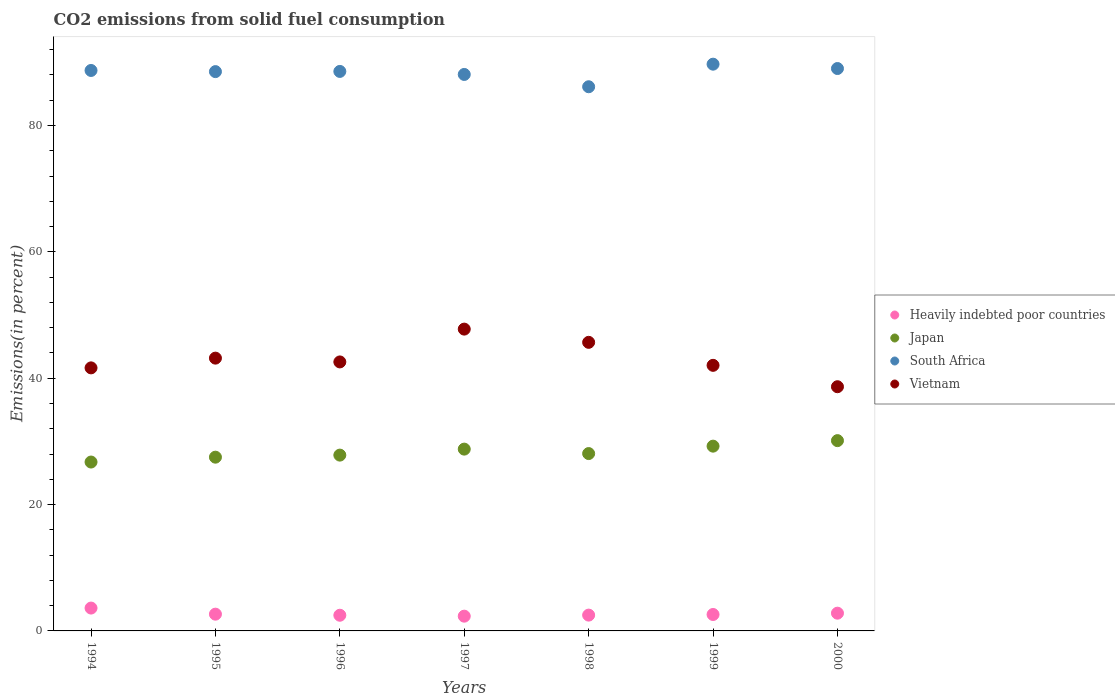Is the number of dotlines equal to the number of legend labels?
Ensure brevity in your answer.  Yes. What is the total CO2 emitted in Heavily indebted poor countries in 1994?
Provide a succinct answer. 3.62. Across all years, what is the maximum total CO2 emitted in Heavily indebted poor countries?
Make the answer very short. 3.62. Across all years, what is the minimum total CO2 emitted in South Africa?
Your response must be concise. 86.13. What is the total total CO2 emitted in Heavily indebted poor countries in the graph?
Your response must be concise. 19. What is the difference between the total CO2 emitted in Heavily indebted poor countries in 1995 and that in 1997?
Provide a succinct answer. 0.32. What is the difference between the total CO2 emitted in Japan in 1994 and the total CO2 emitted in Vietnam in 2000?
Offer a terse response. -11.92. What is the average total CO2 emitted in Heavily indebted poor countries per year?
Provide a succinct answer. 2.71. In the year 1994, what is the difference between the total CO2 emitted in Vietnam and total CO2 emitted in South Africa?
Make the answer very short. -47.07. In how many years, is the total CO2 emitted in Heavily indebted poor countries greater than 56 %?
Your response must be concise. 0. What is the ratio of the total CO2 emitted in Japan in 1994 to that in 2000?
Your answer should be compact. 0.89. What is the difference between the highest and the second highest total CO2 emitted in Heavily indebted poor countries?
Your response must be concise. 0.81. What is the difference between the highest and the lowest total CO2 emitted in South Africa?
Offer a terse response. 3.57. Is the sum of the total CO2 emitted in Vietnam in 1996 and 1998 greater than the maximum total CO2 emitted in South Africa across all years?
Provide a short and direct response. No. Does the total CO2 emitted in Heavily indebted poor countries monotonically increase over the years?
Give a very brief answer. No. Is the total CO2 emitted in Heavily indebted poor countries strictly greater than the total CO2 emitted in South Africa over the years?
Keep it short and to the point. No. Is the total CO2 emitted in Japan strictly less than the total CO2 emitted in South Africa over the years?
Offer a very short reply. Yes. How many dotlines are there?
Your response must be concise. 4. Does the graph contain any zero values?
Offer a terse response. No. Does the graph contain grids?
Provide a short and direct response. No. How many legend labels are there?
Provide a short and direct response. 4. What is the title of the graph?
Give a very brief answer. CO2 emissions from solid fuel consumption. Does "Virgin Islands" appear as one of the legend labels in the graph?
Provide a succinct answer. No. What is the label or title of the Y-axis?
Ensure brevity in your answer.  Emissions(in percent). What is the Emissions(in percent) in Heavily indebted poor countries in 1994?
Offer a very short reply. 3.62. What is the Emissions(in percent) in Japan in 1994?
Your answer should be compact. 26.73. What is the Emissions(in percent) in South Africa in 1994?
Ensure brevity in your answer.  88.7. What is the Emissions(in percent) of Vietnam in 1994?
Offer a terse response. 41.63. What is the Emissions(in percent) of Heavily indebted poor countries in 1995?
Your answer should be compact. 2.65. What is the Emissions(in percent) in Japan in 1995?
Your response must be concise. 27.5. What is the Emissions(in percent) of South Africa in 1995?
Your response must be concise. 88.52. What is the Emissions(in percent) in Vietnam in 1995?
Make the answer very short. 43.17. What is the Emissions(in percent) of Heavily indebted poor countries in 1996?
Your answer should be compact. 2.48. What is the Emissions(in percent) of Japan in 1996?
Your answer should be very brief. 27.83. What is the Emissions(in percent) of South Africa in 1996?
Your answer should be very brief. 88.55. What is the Emissions(in percent) in Vietnam in 1996?
Your answer should be very brief. 42.57. What is the Emissions(in percent) of Heavily indebted poor countries in 1997?
Make the answer very short. 2.34. What is the Emissions(in percent) in Japan in 1997?
Offer a terse response. 28.77. What is the Emissions(in percent) in South Africa in 1997?
Offer a very short reply. 88.07. What is the Emissions(in percent) in Vietnam in 1997?
Offer a very short reply. 47.77. What is the Emissions(in percent) in Heavily indebted poor countries in 1998?
Keep it short and to the point. 2.5. What is the Emissions(in percent) of Japan in 1998?
Your answer should be compact. 28.07. What is the Emissions(in percent) in South Africa in 1998?
Your response must be concise. 86.13. What is the Emissions(in percent) in Vietnam in 1998?
Provide a succinct answer. 45.67. What is the Emissions(in percent) in Heavily indebted poor countries in 1999?
Provide a succinct answer. 2.6. What is the Emissions(in percent) in Japan in 1999?
Keep it short and to the point. 29.24. What is the Emissions(in percent) in South Africa in 1999?
Keep it short and to the point. 89.7. What is the Emissions(in percent) in Vietnam in 1999?
Make the answer very short. 42.03. What is the Emissions(in percent) of Heavily indebted poor countries in 2000?
Provide a short and direct response. 2.81. What is the Emissions(in percent) in Japan in 2000?
Give a very brief answer. 30.12. What is the Emissions(in percent) in South Africa in 2000?
Give a very brief answer. 89.01. What is the Emissions(in percent) in Vietnam in 2000?
Your answer should be very brief. 38.65. Across all years, what is the maximum Emissions(in percent) of Heavily indebted poor countries?
Provide a succinct answer. 3.62. Across all years, what is the maximum Emissions(in percent) of Japan?
Offer a very short reply. 30.12. Across all years, what is the maximum Emissions(in percent) of South Africa?
Provide a succinct answer. 89.7. Across all years, what is the maximum Emissions(in percent) of Vietnam?
Your answer should be very brief. 47.77. Across all years, what is the minimum Emissions(in percent) in Heavily indebted poor countries?
Provide a short and direct response. 2.34. Across all years, what is the minimum Emissions(in percent) of Japan?
Offer a very short reply. 26.73. Across all years, what is the minimum Emissions(in percent) of South Africa?
Provide a succinct answer. 86.13. Across all years, what is the minimum Emissions(in percent) of Vietnam?
Offer a terse response. 38.65. What is the total Emissions(in percent) in Heavily indebted poor countries in the graph?
Offer a very short reply. 19. What is the total Emissions(in percent) of Japan in the graph?
Give a very brief answer. 198.26. What is the total Emissions(in percent) in South Africa in the graph?
Your answer should be very brief. 618.69. What is the total Emissions(in percent) of Vietnam in the graph?
Your answer should be very brief. 301.51. What is the difference between the Emissions(in percent) of Heavily indebted poor countries in 1994 and that in 1995?
Offer a terse response. 0.97. What is the difference between the Emissions(in percent) of Japan in 1994 and that in 1995?
Ensure brevity in your answer.  -0.77. What is the difference between the Emissions(in percent) of South Africa in 1994 and that in 1995?
Give a very brief answer. 0.18. What is the difference between the Emissions(in percent) in Vietnam in 1994 and that in 1995?
Your answer should be compact. -1.54. What is the difference between the Emissions(in percent) in Heavily indebted poor countries in 1994 and that in 1996?
Make the answer very short. 1.14. What is the difference between the Emissions(in percent) in Japan in 1994 and that in 1996?
Ensure brevity in your answer.  -1.1. What is the difference between the Emissions(in percent) in South Africa in 1994 and that in 1996?
Ensure brevity in your answer.  0.15. What is the difference between the Emissions(in percent) in Vietnam in 1994 and that in 1996?
Keep it short and to the point. -0.94. What is the difference between the Emissions(in percent) of Heavily indebted poor countries in 1994 and that in 1997?
Give a very brief answer. 1.28. What is the difference between the Emissions(in percent) of Japan in 1994 and that in 1997?
Ensure brevity in your answer.  -2.04. What is the difference between the Emissions(in percent) of South Africa in 1994 and that in 1997?
Provide a short and direct response. 0.63. What is the difference between the Emissions(in percent) of Vietnam in 1994 and that in 1997?
Your answer should be compact. -6.14. What is the difference between the Emissions(in percent) in Heavily indebted poor countries in 1994 and that in 1998?
Your answer should be compact. 1.11. What is the difference between the Emissions(in percent) in Japan in 1994 and that in 1998?
Your response must be concise. -1.34. What is the difference between the Emissions(in percent) of South Africa in 1994 and that in 1998?
Offer a very short reply. 2.58. What is the difference between the Emissions(in percent) of Vietnam in 1994 and that in 1998?
Your response must be concise. -4.04. What is the difference between the Emissions(in percent) of Heavily indebted poor countries in 1994 and that in 1999?
Provide a succinct answer. 1.02. What is the difference between the Emissions(in percent) of Japan in 1994 and that in 1999?
Offer a terse response. -2.51. What is the difference between the Emissions(in percent) of South Africa in 1994 and that in 1999?
Your answer should be compact. -1. What is the difference between the Emissions(in percent) of Vietnam in 1994 and that in 1999?
Make the answer very short. -0.4. What is the difference between the Emissions(in percent) in Heavily indebted poor countries in 1994 and that in 2000?
Your answer should be compact. 0.81. What is the difference between the Emissions(in percent) in Japan in 1994 and that in 2000?
Your answer should be compact. -3.39. What is the difference between the Emissions(in percent) of South Africa in 1994 and that in 2000?
Offer a terse response. -0.31. What is the difference between the Emissions(in percent) in Vietnam in 1994 and that in 2000?
Provide a succinct answer. 2.98. What is the difference between the Emissions(in percent) of Heavily indebted poor countries in 1995 and that in 1996?
Keep it short and to the point. 0.17. What is the difference between the Emissions(in percent) of Japan in 1995 and that in 1996?
Offer a very short reply. -0.33. What is the difference between the Emissions(in percent) of South Africa in 1995 and that in 1996?
Offer a terse response. -0.03. What is the difference between the Emissions(in percent) in Vietnam in 1995 and that in 1996?
Give a very brief answer. 0.6. What is the difference between the Emissions(in percent) in Heavily indebted poor countries in 1995 and that in 1997?
Offer a very short reply. 0.32. What is the difference between the Emissions(in percent) of Japan in 1995 and that in 1997?
Offer a very short reply. -1.27. What is the difference between the Emissions(in percent) in South Africa in 1995 and that in 1997?
Keep it short and to the point. 0.45. What is the difference between the Emissions(in percent) in Vietnam in 1995 and that in 1997?
Offer a very short reply. -4.59. What is the difference between the Emissions(in percent) of Heavily indebted poor countries in 1995 and that in 1998?
Make the answer very short. 0.15. What is the difference between the Emissions(in percent) in Japan in 1995 and that in 1998?
Offer a very short reply. -0.57. What is the difference between the Emissions(in percent) in South Africa in 1995 and that in 1998?
Provide a short and direct response. 2.39. What is the difference between the Emissions(in percent) of Vietnam in 1995 and that in 1998?
Provide a short and direct response. -2.5. What is the difference between the Emissions(in percent) in Heavily indebted poor countries in 1995 and that in 1999?
Your answer should be very brief. 0.05. What is the difference between the Emissions(in percent) of Japan in 1995 and that in 1999?
Offer a very short reply. -1.74. What is the difference between the Emissions(in percent) of South Africa in 1995 and that in 1999?
Provide a short and direct response. -1.18. What is the difference between the Emissions(in percent) of Vietnam in 1995 and that in 1999?
Give a very brief answer. 1.14. What is the difference between the Emissions(in percent) in Heavily indebted poor countries in 1995 and that in 2000?
Make the answer very short. -0.16. What is the difference between the Emissions(in percent) of Japan in 1995 and that in 2000?
Give a very brief answer. -2.62. What is the difference between the Emissions(in percent) in South Africa in 1995 and that in 2000?
Provide a short and direct response. -0.49. What is the difference between the Emissions(in percent) of Vietnam in 1995 and that in 2000?
Provide a succinct answer. 4.52. What is the difference between the Emissions(in percent) of Heavily indebted poor countries in 1996 and that in 1997?
Give a very brief answer. 0.15. What is the difference between the Emissions(in percent) in Japan in 1996 and that in 1997?
Your answer should be very brief. -0.95. What is the difference between the Emissions(in percent) of South Africa in 1996 and that in 1997?
Offer a very short reply. 0.48. What is the difference between the Emissions(in percent) in Vietnam in 1996 and that in 1997?
Your response must be concise. -5.19. What is the difference between the Emissions(in percent) of Heavily indebted poor countries in 1996 and that in 1998?
Offer a terse response. -0.02. What is the difference between the Emissions(in percent) in Japan in 1996 and that in 1998?
Offer a very short reply. -0.25. What is the difference between the Emissions(in percent) in South Africa in 1996 and that in 1998?
Offer a terse response. 2.43. What is the difference between the Emissions(in percent) of Vietnam in 1996 and that in 1998?
Your answer should be very brief. -3.1. What is the difference between the Emissions(in percent) in Heavily indebted poor countries in 1996 and that in 1999?
Give a very brief answer. -0.12. What is the difference between the Emissions(in percent) in Japan in 1996 and that in 1999?
Give a very brief answer. -1.42. What is the difference between the Emissions(in percent) of South Africa in 1996 and that in 1999?
Offer a very short reply. -1.15. What is the difference between the Emissions(in percent) in Vietnam in 1996 and that in 1999?
Your answer should be compact. 0.54. What is the difference between the Emissions(in percent) in Heavily indebted poor countries in 1996 and that in 2000?
Provide a short and direct response. -0.33. What is the difference between the Emissions(in percent) of Japan in 1996 and that in 2000?
Your answer should be compact. -2.29. What is the difference between the Emissions(in percent) in South Africa in 1996 and that in 2000?
Make the answer very short. -0.46. What is the difference between the Emissions(in percent) in Vietnam in 1996 and that in 2000?
Your response must be concise. 3.93. What is the difference between the Emissions(in percent) in Heavily indebted poor countries in 1997 and that in 1998?
Make the answer very short. -0.17. What is the difference between the Emissions(in percent) in Japan in 1997 and that in 1998?
Offer a very short reply. 0.7. What is the difference between the Emissions(in percent) of South Africa in 1997 and that in 1998?
Make the answer very short. 1.95. What is the difference between the Emissions(in percent) in Vietnam in 1997 and that in 1998?
Offer a terse response. 2.09. What is the difference between the Emissions(in percent) of Heavily indebted poor countries in 1997 and that in 1999?
Provide a short and direct response. -0.26. What is the difference between the Emissions(in percent) of Japan in 1997 and that in 1999?
Keep it short and to the point. -0.47. What is the difference between the Emissions(in percent) in South Africa in 1997 and that in 1999?
Your response must be concise. -1.63. What is the difference between the Emissions(in percent) in Vietnam in 1997 and that in 1999?
Offer a very short reply. 5.73. What is the difference between the Emissions(in percent) in Heavily indebted poor countries in 1997 and that in 2000?
Ensure brevity in your answer.  -0.47. What is the difference between the Emissions(in percent) of Japan in 1997 and that in 2000?
Provide a short and direct response. -1.34. What is the difference between the Emissions(in percent) in South Africa in 1997 and that in 2000?
Your answer should be compact. -0.94. What is the difference between the Emissions(in percent) of Vietnam in 1997 and that in 2000?
Offer a terse response. 9.12. What is the difference between the Emissions(in percent) of Heavily indebted poor countries in 1998 and that in 1999?
Your answer should be very brief. -0.1. What is the difference between the Emissions(in percent) of Japan in 1998 and that in 1999?
Ensure brevity in your answer.  -1.17. What is the difference between the Emissions(in percent) of South Africa in 1998 and that in 1999?
Your response must be concise. -3.57. What is the difference between the Emissions(in percent) in Vietnam in 1998 and that in 1999?
Your answer should be compact. 3.64. What is the difference between the Emissions(in percent) in Heavily indebted poor countries in 1998 and that in 2000?
Your answer should be very brief. -0.3. What is the difference between the Emissions(in percent) of Japan in 1998 and that in 2000?
Your response must be concise. -2.05. What is the difference between the Emissions(in percent) of South Africa in 1998 and that in 2000?
Provide a short and direct response. -2.88. What is the difference between the Emissions(in percent) in Vietnam in 1998 and that in 2000?
Provide a short and direct response. 7.02. What is the difference between the Emissions(in percent) of Heavily indebted poor countries in 1999 and that in 2000?
Your answer should be very brief. -0.21. What is the difference between the Emissions(in percent) of Japan in 1999 and that in 2000?
Keep it short and to the point. -0.87. What is the difference between the Emissions(in percent) in South Africa in 1999 and that in 2000?
Your answer should be compact. 0.69. What is the difference between the Emissions(in percent) of Vietnam in 1999 and that in 2000?
Ensure brevity in your answer.  3.39. What is the difference between the Emissions(in percent) in Heavily indebted poor countries in 1994 and the Emissions(in percent) in Japan in 1995?
Give a very brief answer. -23.88. What is the difference between the Emissions(in percent) of Heavily indebted poor countries in 1994 and the Emissions(in percent) of South Africa in 1995?
Provide a short and direct response. -84.9. What is the difference between the Emissions(in percent) in Heavily indebted poor countries in 1994 and the Emissions(in percent) in Vietnam in 1995?
Your answer should be very brief. -39.56. What is the difference between the Emissions(in percent) of Japan in 1994 and the Emissions(in percent) of South Africa in 1995?
Give a very brief answer. -61.79. What is the difference between the Emissions(in percent) of Japan in 1994 and the Emissions(in percent) of Vietnam in 1995?
Provide a short and direct response. -16.44. What is the difference between the Emissions(in percent) in South Africa in 1994 and the Emissions(in percent) in Vietnam in 1995?
Offer a terse response. 45.53. What is the difference between the Emissions(in percent) in Heavily indebted poor countries in 1994 and the Emissions(in percent) in Japan in 1996?
Ensure brevity in your answer.  -24.21. What is the difference between the Emissions(in percent) in Heavily indebted poor countries in 1994 and the Emissions(in percent) in South Africa in 1996?
Your response must be concise. -84.93. What is the difference between the Emissions(in percent) of Heavily indebted poor countries in 1994 and the Emissions(in percent) of Vietnam in 1996?
Make the answer very short. -38.96. What is the difference between the Emissions(in percent) of Japan in 1994 and the Emissions(in percent) of South Africa in 1996?
Your response must be concise. -61.82. What is the difference between the Emissions(in percent) in Japan in 1994 and the Emissions(in percent) in Vietnam in 1996?
Make the answer very short. -15.85. What is the difference between the Emissions(in percent) of South Africa in 1994 and the Emissions(in percent) of Vietnam in 1996?
Keep it short and to the point. 46.13. What is the difference between the Emissions(in percent) of Heavily indebted poor countries in 1994 and the Emissions(in percent) of Japan in 1997?
Ensure brevity in your answer.  -25.16. What is the difference between the Emissions(in percent) in Heavily indebted poor countries in 1994 and the Emissions(in percent) in South Africa in 1997?
Provide a succinct answer. -84.46. What is the difference between the Emissions(in percent) in Heavily indebted poor countries in 1994 and the Emissions(in percent) in Vietnam in 1997?
Your answer should be compact. -44.15. What is the difference between the Emissions(in percent) of Japan in 1994 and the Emissions(in percent) of South Africa in 1997?
Provide a short and direct response. -61.34. What is the difference between the Emissions(in percent) of Japan in 1994 and the Emissions(in percent) of Vietnam in 1997?
Your answer should be compact. -21.04. What is the difference between the Emissions(in percent) of South Africa in 1994 and the Emissions(in percent) of Vietnam in 1997?
Your answer should be very brief. 40.94. What is the difference between the Emissions(in percent) in Heavily indebted poor countries in 1994 and the Emissions(in percent) in Japan in 1998?
Your answer should be very brief. -24.45. What is the difference between the Emissions(in percent) of Heavily indebted poor countries in 1994 and the Emissions(in percent) of South Africa in 1998?
Offer a terse response. -82.51. What is the difference between the Emissions(in percent) in Heavily indebted poor countries in 1994 and the Emissions(in percent) in Vietnam in 1998?
Make the answer very short. -42.06. What is the difference between the Emissions(in percent) in Japan in 1994 and the Emissions(in percent) in South Africa in 1998?
Offer a terse response. -59.4. What is the difference between the Emissions(in percent) of Japan in 1994 and the Emissions(in percent) of Vietnam in 1998?
Provide a short and direct response. -18.94. What is the difference between the Emissions(in percent) in South Africa in 1994 and the Emissions(in percent) in Vietnam in 1998?
Give a very brief answer. 43.03. What is the difference between the Emissions(in percent) of Heavily indebted poor countries in 1994 and the Emissions(in percent) of Japan in 1999?
Give a very brief answer. -25.63. What is the difference between the Emissions(in percent) of Heavily indebted poor countries in 1994 and the Emissions(in percent) of South Africa in 1999?
Ensure brevity in your answer.  -86.08. What is the difference between the Emissions(in percent) in Heavily indebted poor countries in 1994 and the Emissions(in percent) in Vietnam in 1999?
Provide a short and direct response. -38.42. What is the difference between the Emissions(in percent) in Japan in 1994 and the Emissions(in percent) in South Africa in 1999?
Offer a very short reply. -62.97. What is the difference between the Emissions(in percent) in Japan in 1994 and the Emissions(in percent) in Vietnam in 1999?
Offer a very short reply. -15.3. What is the difference between the Emissions(in percent) of South Africa in 1994 and the Emissions(in percent) of Vietnam in 1999?
Your answer should be very brief. 46.67. What is the difference between the Emissions(in percent) of Heavily indebted poor countries in 1994 and the Emissions(in percent) of Japan in 2000?
Offer a very short reply. -26.5. What is the difference between the Emissions(in percent) of Heavily indebted poor countries in 1994 and the Emissions(in percent) of South Africa in 2000?
Offer a terse response. -85.39. What is the difference between the Emissions(in percent) of Heavily indebted poor countries in 1994 and the Emissions(in percent) of Vietnam in 2000?
Your response must be concise. -35.03. What is the difference between the Emissions(in percent) of Japan in 1994 and the Emissions(in percent) of South Africa in 2000?
Offer a terse response. -62.28. What is the difference between the Emissions(in percent) in Japan in 1994 and the Emissions(in percent) in Vietnam in 2000?
Offer a very short reply. -11.92. What is the difference between the Emissions(in percent) in South Africa in 1994 and the Emissions(in percent) in Vietnam in 2000?
Make the answer very short. 50.05. What is the difference between the Emissions(in percent) in Heavily indebted poor countries in 1995 and the Emissions(in percent) in Japan in 1996?
Your response must be concise. -25.17. What is the difference between the Emissions(in percent) in Heavily indebted poor countries in 1995 and the Emissions(in percent) in South Africa in 1996?
Provide a succinct answer. -85.9. What is the difference between the Emissions(in percent) in Heavily indebted poor countries in 1995 and the Emissions(in percent) in Vietnam in 1996?
Your response must be concise. -39.92. What is the difference between the Emissions(in percent) in Japan in 1995 and the Emissions(in percent) in South Africa in 1996?
Keep it short and to the point. -61.05. What is the difference between the Emissions(in percent) of Japan in 1995 and the Emissions(in percent) of Vietnam in 1996?
Your answer should be very brief. -15.08. What is the difference between the Emissions(in percent) in South Africa in 1995 and the Emissions(in percent) in Vietnam in 1996?
Ensure brevity in your answer.  45.95. What is the difference between the Emissions(in percent) of Heavily indebted poor countries in 1995 and the Emissions(in percent) of Japan in 1997?
Make the answer very short. -26.12. What is the difference between the Emissions(in percent) of Heavily indebted poor countries in 1995 and the Emissions(in percent) of South Africa in 1997?
Make the answer very short. -85.42. What is the difference between the Emissions(in percent) in Heavily indebted poor countries in 1995 and the Emissions(in percent) in Vietnam in 1997?
Keep it short and to the point. -45.12. What is the difference between the Emissions(in percent) of Japan in 1995 and the Emissions(in percent) of South Africa in 1997?
Your response must be concise. -60.58. What is the difference between the Emissions(in percent) in Japan in 1995 and the Emissions(in percent) in Vietnam in 1997?
Offer a terse response. -20.27. What is the difference between the Emissions(in percent) in South Africa in 1995 and the Emissions(in percent) in Vietnam in 1997?
Make the answer very short. 40.75. What is the difference between the Emissions(in percent) in Heavily indebted poor countries in 1995 and the Emissions(in percent) in Japan in 1998?
Your answer should be very brief. -25.42. What is the difference between the Emissions(in percent) of Heavily indebted poor countries in 1995 and the Emissions(in percent) of South Africa in 1998?
Keep it short and to the point. -83.47. What is the difference between the Emissions(in percent) of Heavily indebted poor countries in 1995 and the Emissions(in percent) of Vietnam in 1998?
Ensure brevity in your answer.  -43.02. What is the difference between the Emissions(in percent) in Japan in 1995 and the Emissions(in percent) in South Africa in 1998?
Provide a succinct answer. -58.63. What is the difference between the Emissions(in percent) of Japan in 1995 and the Emissions(in percent) of Vietnam in 1998?
Your answer should be very brief. -18.17. What is the difference between the Emissions(in percent) in South Africa in 1995 and the Emissions(in percent) in Vietnam in 1998?
Provide a succinct answer. 42.85. What is the difference between the Emissions(in percent) in Heavily indebted poor countries in 1995 and the Emissions(in percent) in Japan in 1999?
Your answer should be compact. -26.59. What is the difference between the Emissions(in percent) in Heavily indebted poor countries in 1995 and the Emissions(in percent) in South Africa in 1999?
Provide a short and direct response. -87.05. What is the difference between the Emissions(in percent) in Heavily indebted poor countries in 1995 and the Emissions(in percent) in Vietnam in 1999?
Provide a short and direct response. -39.38. What is the difference between the Emissions(in percent) of Japan in 1995 and the Emissions(in percent) of South Africa in 1999?
Keep it short and to the point. -62.2. What is the difference between the Emissions(in percent) in Japan in 1995 and the Emissions(in percent) in Vietnam in 1999?
Offer a very short reply. -14.53. What is the difference between the Emissions(in percent) of South Africa in 1995 and the Emissions(in percent) of Vietnam in 1999?
Keep it short and to the point. 46.49. What is the difference between the Emissions(in percent) in Heavily indebted poor countries in 1995 and the Emissions(in percent) in Japan in 2000?
Offer a terse response. -27.47. What is the difference between the Emissions(in percent) of Heavily indebted poor countries in 1995 and the Emissions(in percent) of South Africa in 2000?
Your response must be concise. -86.36. What is the difference between the Emissions(in percent) in Heavily indebted poor countries in 1995 and the Emissions(in percent) in Vietnam in 2000?
Your answer should be very brief. -36. What is the difference between the Emissions(in percent) of Japan in 1995 and the Emissions(in percent) of South Africa in 2000?
Offer a terse response. -61.51. What is the difference between the Emissions(in percent) of Japan in 1995 and the Emissions(in percent) of Vietnam in 2000?
Provide a short and direct response. -11.15. What is the difference between the Emissions(in percent) of South Africa in 1995 and the Emissions(in percent) of Vietnam in 2000?
Offer a very short reply. 49.87. What is the difference between the Emissions(in percent) of Heavily indebted poor countries in 1996 and the Emissions(in percent) of Japan in 1997?
Your answer should be compact. -26.29. What is the difference between the Emissions(in percent) of Heavily indebted poor countries in 1996 and the Emissions(in percent) of South Africa in 1997?
Your answer should be compact. -85.59. What is the difference between the Emissions(in percent) of Heavily indebted poor countries in 1996 and the Emissions(in percent) of Vietnam in 1997?
Your answer should be very brief. -45.29. What is the difference between the Emissions(in percent) of Japan in 1996 and the Emissions(in percent) of South Africa in 1997?
Offer a very short reply. -60.25. What is the difference between the Emissions(in percent) in Japan in 1996 and the Emissions(in percent) in Vietnam in 1997?
Give a very brief answer. -19.94. What is the difference between the Emissions(in percent) in South Africa in 1996 and the Emissions(in percent) in Vietnam in 1997?
Your answer should be compact. 40.78. What is the difference between the Emissions(in percent) in Heavily indebted poor countries in 1996 and the Emissions(in percent) in Japan in 1998?
Ensure brevity in your answer.  -25.59. What is the difference between the Emissions(in percent) in Heavily indebted poor countries in 1996 and the Emissions(in percent) in South Africa in 1998?
Ensure brevity in your answer.  -83.65. What is the difference between the Emissions(in percent) of Heavily indebted poor countries in 1996 and the Emissions(in percent) of Vietnam in 1998?
Provide a short and direct response. -43.19. What is the difference between the Emissions(in percent) in Japan in 1996 and the Emissions(in percent) in South Africa in 1998?
Keep it short and to the point. -58.3. What is the difference between the Emissions(in percent) in Japan in 1996 and the Emissions(in percent) in Vietnam in 1998?
Your answer should be very brief. -17.85. What is the difference between the Emissions(in percent) in South Africa in 1996 and the Emissions(in percent) in Vietnam in 1998?
Offer a terse response. 42.88. What is the difference between the Emissions(in percent) in Heavily indebted poor countries in 1996 and the Emissions(in percent) in Japan in 1999?
Your answer should be compact. -26.76. What is the difference between the Emissions(in percent) of Heavily indebted poor countries in 1996 and the Emissions(in percent) of South Africa in 1999?
Ensure brevity in your answer.  -87.22. What is the difference between the Emissions(in percent) in Heavily indebted poor countries in 1996 and the Emissions(in percent) in Vietnam in 1999?
Offer a very short reply. -39.55. What is the difference between the Emissions(in percent) in Japan in 1996 and the Emissions(in percent) in South Africa in 1999?
Offer a terse response. -61.87. What is the difference between the Emissions(in percent) of Japan in 1996 and the Emissions(in percent) of Vietnam in 1999?
Give a very brief answer. -14.21. What is the difference between the Emissions(in percent) in South Africa in 1996 and the Emissions(in percent) in Vietnam in 1999?
Keep it short and to the point. 46.52. What is the difference between the Emissions(in percent) in Heavily indebted poor countries in 1996 and the Emissions(in percent) in Japan in 2000?
Provide a short and direct response. -27.64. What is the difference between the Emissions(in percent) in Heavily indebted poor countries in 1996 and the Emissions(in percent) in South Africa in 2000?
Offer a terse response. -86.53. What is the difference between the Emissions(in percent) of Heavily indebted poor countries in 1996 and the Emissions(in percent) of Vietnam in 2000?
Give a very brief answer. -36.17. What is the difference between the Emissions(in percent) of Japan in 1996 and the Emissions(in percent) of South Africa in 2000?
Your answer should be compact. -61.19. What is the difference between the Emissions(in percent) of Japan in 1996 and the Emissions(in percent) of Vietnam in 2000?
Your answer should be compact. -10.82. What is the difference between the Emissions(in percent) in South Africa in 1996 and the Emissions(in percent) in Vietnam in 2000?
Your response must be concise. 49.9. What is the difference between the Emissions(in percent) of Heavily indebted poor countries in 1997 and the Emissions(in percent) of Japan in 1998?
Give a very brief answer. -25.74. What is the difference between the Emissions(in percent) in Heavily indebted poor countries in 1997 and the Emissions(in percent) in South Africa in 1998?
Give a very brief answer. -83.79. What is the difference between the Emissions(in percent) of Heavily indebted poor countries in 1997 and the Emissions(in percent) of Vietnam in 1998?
Make the answer very short. -43.34. What is the difference between the Emissions(in percent) in Japan in 1997 and the Emissions(in percent) in South Africa in 1998?
Offer a terse response. -57.35. What is the difference between the Emissions(in percent) in Japan in 1997 and the Emissions(in percent) in Vietnam in 1998?
Your answer should be very brief. -16.9. What is the difference between the Emissions(in percent) of South Africa in 1997 and the Emissions(in percent) of Vietnam in 1998?
Your answer should be very brief. 42.4. What is the difference between the Emissions(in percent) in Heavily indebted poor countries in 1997 and the Emissions(in percent) in Japan in 1999?
Ensure brevity in your answer.  -26.91. What is the difference between the Emissions(in percent) in Heavily indebted poor countries in 1997 and the Emissions(in percent) in South Africa in 1999?
Your answer should be compact. -87.36. What is the difference between the Emissions(in percent) in Heavily indebted poor countries in 1997 and the Emissions(in percent) in Vietnam in 1999?
Offer a terse response. -39.7. What is the difference between the Emissions(in percent) of Japan in 1997 and the Emissions(in percent) of South Africa in 1999?
Make the answer very short. -60.93. What is the difference between the Emissions(in percent) of Japan in 1997 and the Emissions(in percent) of Vietnam in 1999?
Ensure brevity in your answer.  -13.26. What is the difference between the Emissions(in percent) in South Africa in 1997 and the Emissions(in percent) in Vietnam in 1999?
Offer a terse response. 46.04. What is the difference between the Emissions(in percent) in Heavily indebted poor countries in 1997 and the Emissions(in percent) in Japan in 2000?
Make the answer very short. -27.78. What is the difference between the Emissions(in percent) in Heavily indebted poor countries in 1997 and the Emissions(in percent) in South Africa in 2000?
Offer a terse response. -86.68. What is the difference between the Emissions(in percent) in Heavily indebted poor countries in 1997 and the Emissions(in percent) in Vietnam in 2000?
Provide a succinct answer. -36.31. What is the difference between the Emissions(in percent) in Japan in 1997 and the Emissions(in percent) in South Africa in 2000?
Offer a terse response. -60.24. What is the difference between the Emissions(in percent) in Japan in 1997 and the Emissions(in percent) in Vietnam in 2000?
Give a very brief answer. -9.88. What is the difference between the Emissions(in percent) in South Africa in 1997 and the Emissions(in percent) in Vietnam in 2000?
Your response must be concise. 49.43. What is the difference between the Emissions(in percent) of Heavily indebted poor countries in 1998 and the Emissions(in percent) of Japan in 1999?
Ensure brevity in your answer.  -26.74. What is the difference between the Emissions(in percent) in Heavily indebted poor countries in 1998 and the Emissions(in percent) in South Africa in 1999?
Offer a terse response. -87.2. What is the difference between the Emissions(in percent) of Heavily indebted poor countries in 1998 and the Emissions(in percent) of Vietnam in 1999?
Your answer should be compact. -39.53. What is the difference between the Emissions(in percent) of Japan in 1998 and the Emissions(in percent) of South Africa in 1999?
Make the answer very short. -61.63. What is the difference between the Emissions(in percent) in Japan in 1998 and the Emissions(in percent) in Vietnam in 1999?
Keep it short and to the point. -13.96. What is the difference between the Emissions(in percent) in South Africa in 1998 and the Emissions(in percent) in Vietnam in 1999?
Ensure brevity in your answer.  44.09. What is the difference between the Emissions(in percent) of Heavily indebted poor countries in 1998 and the Emissions(in percent) of Japan in 2000?
Your response must be concise. -27.61. What is the difference between the Emissions(in percent) of Heavily indebted poor countries in 1998 and the Emissions(in percent) of South Africa in 2000?
Provide a short and direct response. -86.51. What is the difference between the Emissions(in percent) of Heavily indebted poor countries in 1998 and the Emissions(in percent) of Vietnam in 2000?
Give a very brief answer. -36.15. What is the difference between the Emissions(in percent) of Japan in 1998 and the Emissions(in percent) of South Africa in 2000?
Your answer should be compact. -60.94. What is the difference between the Emissions(in percent) in Japan in 1998 and the Emissions(in percent) in Vietnam in 2000?
Keep it short and to the point. -10.58. What is the difference between the Emissions(in percent) of South Africa in 1998 and the Emissions(in percent) of Vietnam in 2000?
Give a very brief answer. 47.48. What is the difference between the Emissions(in percent) of Heavily indebted poor countries in 1999 and the Emissions(in percent) of Japan in 2000?
Make the answer very short. -27.52. What is the difference between the Emissions(in percent) in Heavily indebted poor countries in 1999 and the Emissions(in percent) in South Africa in 2000?
Provide a succinct answer. -86.41. What is the difference between the Emissions(in percent) in Heavily indebted poor countries in 1999 and the Emissions(in percent) in Vietnam in 2000?
Provide a short and direct response. -36.05. What is the difference between the Emissions(in percent) of Japan in 1999 and the Emissions(in percent) of South Africa in 2000?
Your answer should be very brief. -59.77. What is the difference between the Emissions(in percent) in Japan in 1999 and the Emissions(in percent) in Vietnam in 2000?
Ensure brevity in your answer.  -9.41. What is the difference between the Emissions(in percent) in South Africa in 1999 and the Emissions(in percent) in Vietnam in 2000?
Offer a very short reply. 51.05. What is the average Emissions(in percent) of Heavily indebted poor countries per year?
Provide a succinct answer. 2.71. What is the average Emissions(in percent) of Japan per year?
Make the answer very short. 28.32. What is the average Emissions(in percent) in South Africa per year?
Ensure brevity in your answer.  88.38. What is the average Emissions(in percent) of Vietnam per year?
Your answer should be very brief. 43.07. In the year 1994, what is the difference between the Emissions(in percent) of Heavily indebted poor countries and Emissions(in percent) of Japan?
Provide a short and direct response. -23.11. In the year 1994, what is the difference between the Emissions(in percent) in Heavily indebted poor countries and Emissions(in percent) in South Africa?
Your response must be concise. -85.09. In the year 1994, what is the difference between the Emissions(in percent) of Heavily indebted poor countries and Emissions(in percent) of Vietnam?
Provide a short and direct response. -38.02. In the year 1994, what is the difference between the Emissions(in percent) in Japan and Emissions(in percent) in South Africa?
Keep it short and to the point. -61.97. In the year 1994, what is the difference between the Emissions(in percent) in Japan and Emissions(in percent) in Vietnam?
Ensure brevity in your answer.  -14.9. In the year 1994, what is the difference between the Emissions(in percent) in South Africa and Emissions(in percent) in Vietnam?
Ensure brevity in your answer.  47.07. In the year 1995, what is the difference between the Emissions(in percent) in Heavily indebted poor countries and Emissions(in percent) in Japan?
Offer a terse response. -24.85. In the year 1995, what is the difference between the Emissions(in percent) of Heavily indebted poor countries and Emissions(in percent) of South Africa?
Provide a succinct answer. -85.87. In the year 1995, what is the difference between the Emissions(in percent) of Heavily indebted poor countries and Emissions(in percent) of Vietnam?
Offer a terse response. -40.52. In the year 1995, what is the difference between the Emissions(in percent) of Japan and Emissions(in percent) of South Africa?
Ensure brevity in your answer.  -61.02. In the year 1995, what is the difference between the Emissions(in percent) in Japan and Emissions(in percent) in Vietnam?
Provide a short and direct response. -15.67. In the year 1995, what is the difference between the Emissions(in percent) in South Africa and Emissions(in percent) in Vietnam?
Your response must be concise. 45.35. In the year 1996, what is the difference between the Emissions(in percent) of Heavily indebted poor countries and Emissions(in percent) of Japan?
Offer a terse response. -25.34. In the year 1996, what is the difference between the Emissions(in percent) in Heavily indebted poor countries and Emissions(in percent) in South Africa?
Provide a short and direct response. -86.07. In the year 1996, what is the difference between the Emissions(in percent) in Heavily indebted poor countries and Emissions(in percent) in Vietnam?
Provide a short and direct response. -40.09. In the year 1996, what is the difference between the Emissions(in percent) in Japan and Emissions(in percent) in South Africa?
Your answer should be compact. -60.73. In the year 1996, what is the difference between the Emissions(in percent) in Japan and Emissions(in percent) in Vietnam?
Your response must be concise. -14.75. In the year 1996, what is the difference between the Emissions(in percent) in South Africa and Emissions(in percent) in Vietnam?
Keep it short and to the point. 45.98. In the year 1997, what is the difference between the Emissions(in percent) of Heavily indebted poor countries and Emissions(in percent) of Japan?
Your answer should be very brief. -26.44. In the year 1997, what is the difference between the Emissions(in percent) of Heavily indebted poor countries and Emissions(in percent) of South Africa?
Your response must be concise. -85.74. In the year 1997, what is the difference between the Emissions(in percent) of Heavily indebted poor countries and Emissions(in percent) of Vietnam?
Your response must be concise. -45.43. In the year 1997, what is the difference between the Emissions(in percent) in Japan and Emissions(in percent) in South Africa?
Give a very brief answer. -59.3. In the year 1997, what is the difference between the Emissions(in percent) in Japan and Emissions(in percent) in Vietnam?
Give a very brief answer. -18.99. In the year 1997, what is the difference between the Emissions(in percent) in South Africa and Emissions(in percent) in Vietnam?
Offer a very short reply. 40.31. In the year 1998, what is the difference between the Emissions(in percent) in Heavily indebted poor countries and Emissions(in percent) in Japan?
Keep it short and to the point. -25.57. In the year 1998, what is the difference between the Emissions(in percent) of Heavily indebted poor countries and Emissions(in percent) of South Africa?
Keep it short and to the point. -83.62. In the year 1998, what is the difference between the Emissions(in percent) of Heavily indebted poor countries and Emissions(in percent) of Vietnam?
Make the answer very short. -43.17. In the year 1998, what is the difference between the Emissions(in percent) of Japan and Emissions(in percent) of South Africa?
Provide a short and direct response. -58.06. In the year 1998, what is the difference between the Emissions(in percent) of Japan and Emissions(in percent) of Vietnam?
Make the answer very short. -17.6. In the year 1998, what is the difference between the Emissions(in percent) of South Africa and Emissions(in percent) of Vietnam?
Your response must be concise. 40.45. In the year 1999, what is the difference between the Emissions(in percent) in Heavily indebted poor countries and Emissions(in percent) in Japan?
Provide a short and direct response. -26.64. In the year 1999, what is the difference between the Emissions(in percent) in Heavily indebted poor countries and Emissions(in percent) in South Africa?
Provide a short and direct response. -87.1. In the year 1999, what is the difference between the Emissions(in percent) of Heavily indebted poor countries and Emissions(in percent) of Vietnam?
Offer a terse response. -39.43. In the year 1999, what is the difference between the Emissions(in percent) of Japan and Emissions(in percent) of South Africa?
Your answer should be very brief. -60.46. In the year 1999, what is the difference between the Emissions(in percent) of Japan and Emissions(in percent) of Vietnam?
Provide a short and direct response. -12.79. In the year 1999, what is the difference between the Emissions(in percent) of South Africa and Emissions(in percent) of Vietnam?
Provide a succinct answer. 47.67. In the year 2000, what is the difference between the Emissions(in percent) of Heavily indebted poor countries and Emissions(in percent) of Japan?
Offer a terse response. -27.31. In the year 2000, what is the difference between the Emissions(in percent) in Heavily indebted poor countries and Emissions(in percent) in South Africa?
Your response must be concise. -86.2. In the year 2000, what is the difference between the Emissions(in percent) in Heavily indebted poor countries and Emissions(in percent) in Vietnam?
Give a very brief answer. -35.84. In the year 2000, what is the difference between the Emissions(in percent) in Japan and Emissions(in percent) in South Africa?
Offer a terse response. -58.89. In the year 2000, what is the difference between the Emissions(in percent) in Japan and Emissions(in percent) in Vietnam?
Offer a terse response. -8.53. In the year 2000, what is the difference between the Emissions(in percent) in South Africa and Emissions(in percent) in Vietnam?
Your answer should be compact. 50.36. What is the ratio of the Emissions(in percent) of Heavily indebted poor countries in 1994 to that in 1995?
Give a very brief answer. 1.36. What is the ratio of the Emissions(in percent) of Japan in 1994 to that in 1995?
Your response must be concise. 0.97. What is the ratio of the Emissions(in percent) in Vietnam in 1994 to that in 1995?
Give a very brief answer. 0.96. What is the ratio of the Emissions(in percent) of Heavily indebted poor countries in 1994 to that in 1996?
Give a very brief answer. 1.46. What is the ratio of the Emissions(in percent) in Japan in 1994 to that in 1996?
Ensure brevity in your answer.  0.96. What is the ratio of the Emissions(in percent) of South Africa in 1994 to that in 1996?
Offer a very short reply. 1. What is the ratio of the Emissions(in percent) of Vietnam in 1994 to that in 1996?
Keep it short and to the point. 0.98. What is the ratio of the Emissions(in percent) of Heavily indebted poor countries in 1994 to that in 1997?
Offer a terse response. 1.55. What is the ratio of the Emissions(in percent) of Japan in 1994 to that in 1997?
Make the answer very short. 0.93. What is the ratio of the Emissions(in percent) in South Africa in 1994 to that in 1997?
Offer a terse response. 1.01. What is the ratio of the Emissions(in percent) of Vietnam in 1994 to that in 1997?
Keep it short and to the point. 0.87. What is the ratio of the Emissions(in percent) of Heavily indebted poor countries in 1994 to that in 1998?
Offer a very short reply. 1.45. What is the ratio of the Emissions(in percent) of Japan in 1994 to that in 1998?
Ensure brevity in your answer.  0.95. What is the ratio of the Emissions(in percent) in South Africa in 1994 to that in 1998?
Give a very brief answer. 1.03. What is the ratio of the Emissions(in percent) of Vietnam in 1994 to that in 1998?
Provide a short and direct response. 0.91. What is the ratio of the Emissions(in percent) in Heavily indebted poor countries in 1994 to that in 1999?
Provide a short and direct response. 1.39. What is the ratio of the Emissions(in percent) in Japan in 1994 to that in 1999?
Ensure brevity in your answer.  0.91. What is the ratio of the Emissions(in percent) of South Africa in 1994 to that in 1999?
Ensure brevity in your answer.  0.99. What is the ratio of the Emissions(in percent) in Vietnam in 1994 to that in 1999?
Make the answer very short. 0.99. What is the ratio of the Emissions(in percent) of Heavily indebted poor countries in 1994 to that in 2000?
Provide a short and direct response. 1.29. What is the ratio of the Emissions(in percent) in Japan in 1994 to that in 2000?
Keep it short and to the point. 0.89. What is the ratio of the Emissions(in percent) in South Africa in 1994 to that in 2000?
Offer a very short reply. 1. What is the ratio of the Emissions(in percent) of Vietnam in 1994 to that in 2000?
Give a very brief answer. 1.08. What is the ratio of the Emissions(in percent) in Heavily indebted poor countries in 1995 to that in 1996?
Make the answer very short. 1.07. What is the ratio of the Emissions(in percent) in Japan in 1995 to that in 1996?
Offer a very short reply. 0.99. What is the ratio of the Emissions(in percent) in South Africa in 1995 to that in 1996?
Keep it short and to the point. 1. What is the ratio of the Emissions(in percent) of Vietnam in 1995 to that in 1996?
Ensure brevity in your answer.  1.01. What is the ratio of the Emissions(in percent) in Heavily indebted poor countries in 1995 to that in 1997?
Your answer should be very brief. 1.14. What is the ratio of the Emissions(in percent) in Japan in 1995 to that in 1997?
Your response must be concise. 0.96. What is the ratio of the Emissions(in percent) of Vietnam in 1995 to that in 1997?
Your answer should be very brief. 0.9. What is the ratio of the Emissions(in percent) in Heavily indebted poor countries in 1995 to that in 1998?
Make the answer very short. 1.06. What is the ratio of the Emissions(in percent) of Japan in 1995 to that in 1998?
Your response must be concise. 0.98. What is the ratio of the Emissions(in percent) of South Africa in 1995 to that in 1998?
Keep it short and to the point. 1.03. What is the ratio of the Emissions(in percent) of Vietnam in 1995 to that in 1998?
Keep it short and to the point. 0.95. What is the ratio of the Emissions(in percent) of Heavily indebted poor countries in 1995 to that in 1999?
Provide a succinct answer. 1.02. What is the ratio of the Emissions(in percent) in Japan in 1995 to that in 1999?
Keep it short and to the point. 0.94. What is the ratio of the Emissions(in percent) of South Africa in 1995 to that in 1999?
Keep it short and to the point. 0.99. What is the ratio of the Emissions(in percent) in Vietnam in 1995 to that in 1999?
Give a very brief answer. 1.03. What is the ratio of the Emissions(in percent) in Heavily indebted poor countries in 1995 to that in 2000?
Ensure brevity in your answer.  0.94. What is the ratio of the Emissions(in percent) of Japan in 1995 to that in 2000?
Make the answer very short. 0.91. What is the ratio of the Emissions(in percent) in South Africa in 1995 to that in 2000?
Ensure brevity in your answer.  0.99. What is the ratio of the Emissions(in percent) of Vietnam in 1995 to that in 2000?
Provide a succinct answer. 1.12. What is the ratio of the Emissions(in percent) of Heavily indebted poor countries in 1996 to that in 1997?
Provide a short and direct response. 1.06. What is the ratio of the Emissions(in percent) in Japan in 1996 to that in 1997?
Give a very brief answer. 0.97. What is the ratio of the Emissions(in percent) of South Africa in 1996 to that in 1997?
Your response must be concise. 1.01. What is the ratio of the Emissions(in percent) in Vietnam in 1996 to that in 1997?
Your answer should be compact. 0.89. What is the ratio of the Emissions(in percent) of Heavily indebted poor countries in 1996 to that in 1998?
Offer a very short reply. 0.99. What is the ratio of the Emissions(in percent) of Japan in 1996 to that in 1998?
Give a very brief answer. 0.99. What is the ratio of the Emissions(in percent) in South Africa in 1996 to that in 1998?
Your response must be concise. 1.03. What is the ratio of the Emissions(in percent) of Vietnam in 1996 to that in 1998?
Offer a very short reply. 0.93. What is the ratio of the Emissions(in percent) of Heavily indebted poor countries in 1996 to that in 1999?
Offer a very short reply. 0.95. What is the ratio of the Emissions(in percent) in Japan in 1996 to that in 1999?
Give a very brief answer. 0.95. What is the ratio of the Emissions(in percent) in South Africa in 1996 to that in 1999?
Keep it short and to the point. 0.99. What is the ratio of the Emissions(in percent) of Vietnam in 1996 to that in 1999?
Offer a very short reply. 1.01. What is the ratio of the Emissions(in percent) of Heavily indebted poor countries in 1996 to that in 2000?
Ensure brevity in your answer.  0.88. What is the ratio of the Emissions(in percent) in Japan in 1996 to that in 2000?
Make the answer very short. 0.92. What is the ratio of the Emissions(in percent) in Vietnam in 1996 to that in 2000?
Your response must be concise. 1.1. What is the ratio of the Emissions(in percent) in Heavily indebted poor countries in 1997 to that in 1998?
Give a very brief answer. 0.93. What is the ratio of the Emissions(in percent) in Japan in 1997 to that in 1998?
Keep it short and to the point. 1.02. What is the ratio of the Emissions(in percent) of South Africa in 1997 to that in 1998?
Make the answer very short. 1.02. What is the ratio of the Emissions(in percent) in Vietnam in 1997 to that in 1998?
Provide a succinct answer. 1.05. What is the ratio of the Emissions(in percent) in Heavily indebted poor countries in 1997 to that in 1999?
Offer a very short reply. 0.9. What is the ratio of the Emissions(in percent) in Japan in 1997 to that in 1999?
Offer a terse response. 0.98. What is the ratio of the Emissions(in percent) in South Africa in 1997 to that in 1999?
Keep it short and to the point. 0.98. What is the ratio of the Emissions(in percent) of Vietnam in 1997 to that in 1999?
Provide a succinct answer. 1.14. What is the ratio of the Emissions(in percent) of Heavily indebted poor countries in 1997 to that in 2000?
Offer a very short reply. 0.83. What is the ratio of the Emissions(in percent) of Japan in 1997 to that in 2000?
Make the answer very short. 0.96. What is the ratio of the Emissions(in percent) of Vietnam in 1997 to that in 2000?
Give a very brief answer. 1.24. What is the ratio of the Emissions(in percent) of Heavily indebted poor countries in 1998 to that in 1999?
Offer a very short reply. 0.96. What is the ratio of the Emissions(in percent) of Japan in 1998 to that in 1999?
Make the answer very short. 0.96. What is the ratio of the Emissions(in percent) in South Africa in 1998 to that in 1999?
Offer a terse response. 0.96. What is the ratio of the Emissions(in percent) of Vietnam in 1998 to that in 1999?
Make the answer very short. 1.09. What is the ratio of the Emissions(in percent) of Heavily indebted poor countries in 1998 to that in 2000?
Your answer should be very brief. 0.89. What is the ratio of the Emissions(in percent) of Japan in 1998 to that in 2000?
Keep it short and to the point. 0.93. What is the ratio of the Emissions(in percent) of South Africa in 1998 to that in 2000?
Make the answer very short. 0.97. What is the ratio of the Emissions(in percent) in Vietnam in 1998 to that in 2000?
Your answer should be compact. 1.18. What is the ratio of the Emissions(in percent) in Heavily indebted poor countries in 1999 to that in 2000?
Your answer should be compact. 0.93. What is the ratio of the Emissions(in percent) in South Africa in 1999 to that in 2000?
Provide a short and direct response. 1.01. What is the ratio of the Emissions(in percent) in Vietnam in 1999 to that in 2000?
Make the answer very short. 1.09. What is the difference between the highest and the second highest Emissions(in percent) in Heavily indebted poor countries?
Offer a very short reply. 0.81. What is the difference between the highest and the second highest Emissions(in percent) of Japan?
Your response must be concise. 0.87. What is the difference between the highest and the second highest Emissions(in percent) of South Africa?
Provide a succinct answer. 0.69. What is the difference between the highest and the second highest Emissions(in percent) of Vietnam?
Your answer should be compact. 2.09. What is the difference between the highest and the lowest Emissions(in percent) in Heavily indebted poor countries?
Provide a succinct answer. 1.28. What is the difference between the highest and the lowest Emissions(in percent) in Japan?
Offer a very short reply. 3.39. What is the difference between the highest and the lowest Emissions(in percent) of South Africa?
Ensure brevity in your answer.  3.57. What is the difference between the highest and the lowest Emissions(in percent) in Vietnam?
Provide a succinct answer. 9.12. 